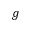<formula> <loc_0><loc_0><loc_500><loc_500>g</formula> 